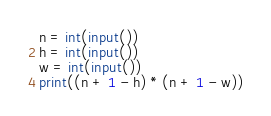Convert code to text. <code><loc_0><loc_0><loc_500><loc_500><_Python_>n = int(input())
h = int(input())
w = int(input())
print((n + 1 - h) * (n + 1 - w))
</code> 